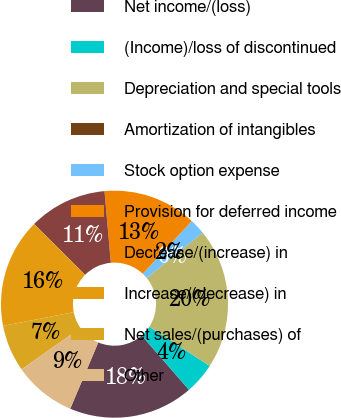Convert chart. <chart><loc_0><loc_0><loc_500><loc_500><pie_chart><fcel>Net income/(loss)<fcel>(Income)/loss of discontinued<fcel>Depreciation and special tools<fcel>Amortization of intangibles<fcel>Stock option expense<fcel>Provision for deferred income<fcel>Decrease/(increase) in<fcel>Increase/(decrease) in<fcel>Net sales/(purchases) of<fcel>Other<nl><fcel>17.77%<fcel>4.45%<fcel>19.99%<fcel>0.01%<fcel>2.23%<fcel>13.33%<fcel>11.11%<fcel>15.55%<fcel>6.67%<fcel>8.89%<nl></chart> 